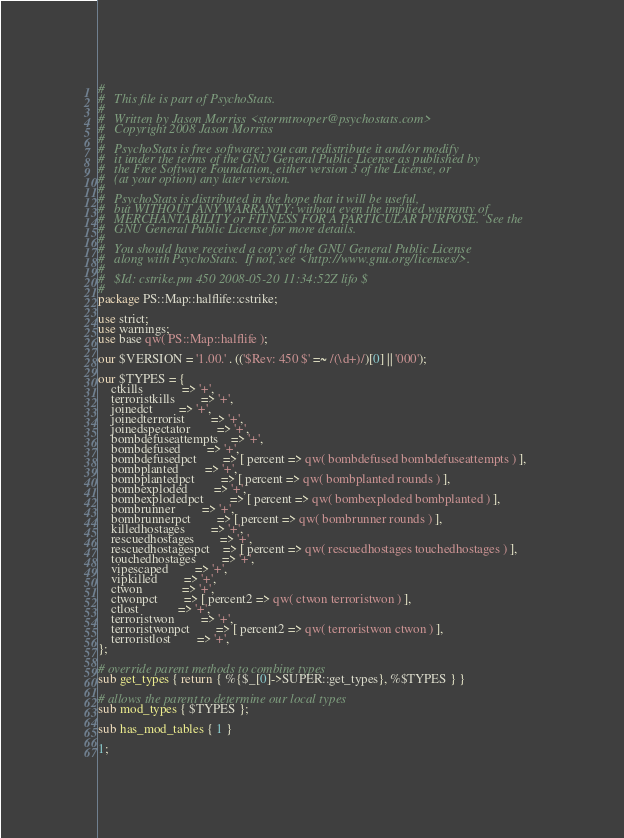Convert code to text. <code><loc_0><loc_0><loc_500><loc_500><_Perl_>#
#	This file is part of PsychoStats.
#
#	Written by Jason Morriss <stormtrooper@psychostats.com>
#	Copyright 2008 Jason Morriss
#
#	PsychoStats is free software: you can redistribute it and/or modify
#	it under the terms of the GNU General Public License as published by
#	the Free Software Foundation, either version 3 of the License, or
#	(at your option) any later version.
#
#	PsychoStats is distributed in the hope that it will be useful,
#	but WITHOUT ANY WARRANTY; without even the implied warranty of
#	MERCHANTABILITY or FITNESS FOR A PARTICULAR PURPOSE.  See the
#	GNU General Public License for more details.
#
#	You should have received a copy of the GNU General Public License
#	along with PsychoStats.  If not, see <http://www.gnu.org/licenses/>.
#
#	$Id: cstrike.pm 450 2008-05-20 11:34:52Z lifo $
#
package PS::Map::halflife::cstrike;

use strict;
use warnings;
use base qw( PS::Map::halflife );

our $VERSION = '1.00.' . (('$Rev: 450 $' =~ /(\d+)/)[0] || '000');

our $TYPES = {
	ctkills			=> '+',
	terroristkills		=> '+',
	joinedct		=> '+',
	joinedterrorist		=> '+',
	joinedspectator		=> '+',
	bombdefuseattempts	=> '+',
	bombdefused		=> '+',
	bombdefusedpct		=> [ percent => qw( bombdefused bombdefuseattempts ) ],
	bombplanted		=> '+',
	bombplantedpct		=> [ percent => qw( bombplanted rounds ) ],
	bombexploded		=> '+',
	bombexplodedpct		=> [ percent => qw( bombexploded bombplanted ) ],
	bombrunner		=> '+',
	bombrunnerpct		=> [ percent => qw( bombrunner rounds ) ],
	killedhostages		=> '+',
	rescuedhostages		=> '+',
	rescuedhostagespct	=> [ percent => qw( rescuedhostages touchedhostages ) ],
	touchedhostages		=> '+',
	vipescaped		=> '+',
	vipkilled		=> '+',
	ctwon			=> '+',
	ctwonpct		=> [ percent2 => qw( ctwon terroristwon ) ],
	ctlost			=> '+',
	terroristwon		=> '+',
	terroristwonpct		=> [ percent2 => qw( terroristwon ctwon ) ],
	terroristlost		=> '+',
};

# override parent methods to combine types
sub get_types { return { %{$_[0]->SUPER::get_types}, %$TYPES } }

# allows the parent to determine our local types
sub mod_types { $TYPES };

sub has_mod_tables { 1 }

1;
</code> 